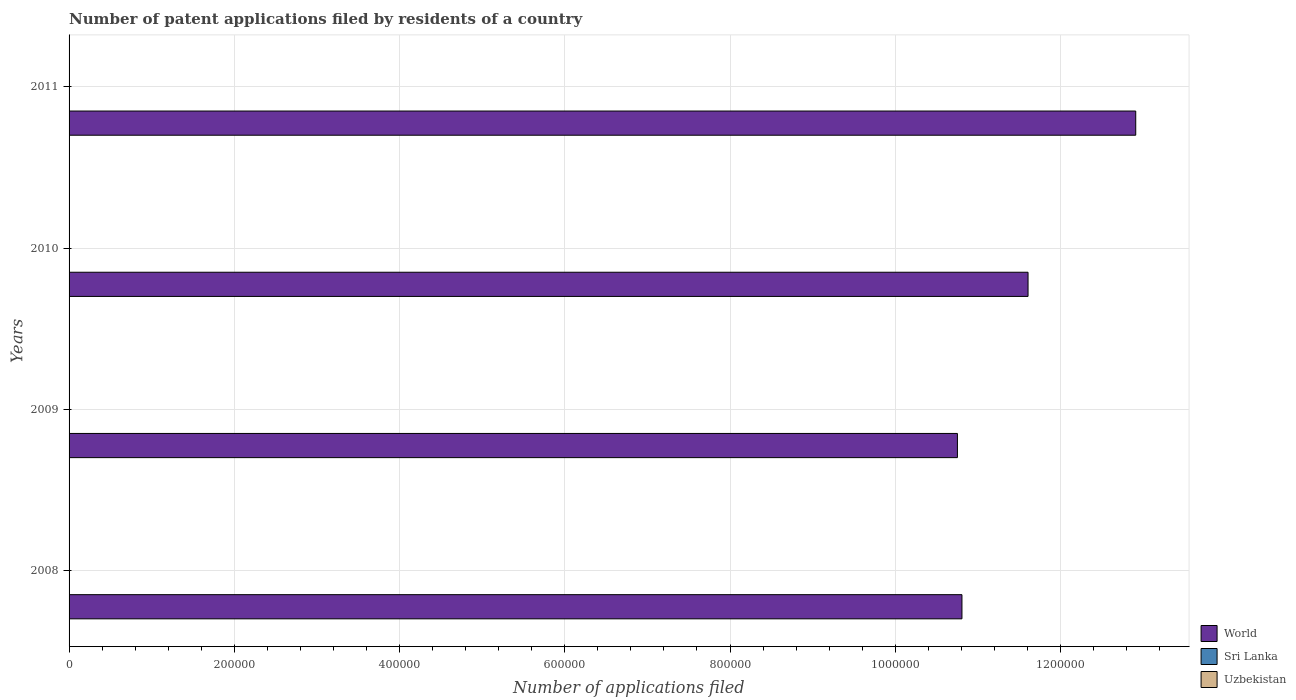How many different coloured bars are there?
Offer a terse response. 3. How many groups of bars are there?
Ensure brevity in your answer.  4. Are the number of bars per tick equal to the number of legend labels?
Make the answer very short. Yes. How many bars are there on the 2nd tick from the top?
Your response must be concise. 3. What is the number of applications filed in World in 2011?
Your response must be concise. 1.29e+06. Across all years, what is the maximum number of applications filed in Sri Lanka?
Offer a very short reply. 225. Across all years, what is the minimum number of applications filed in Uzbekistan?
Provide a short and direct response. 238. In which year was the number of applications filed in Sri Lanka maximum?
Your answer should be very brief. 2010. In which year was the number of applications filed in Sri Lanka minimum?
Keep it short and to the point. 2011. What is the total number of applications filed in Sri Lanka in the graph?
Offer a terse response. 822. What is the difference between the number of applications filed in Sri Lanka in 2010 and that in 2011?
Ensure brevity in your answer.  31. What is the difference between the number of applications filed in World in 2011 and the number of applications filed in Uzbekistan in 2008?
Provide a short and direct response. 1.29e+06. What is the average number of applications filed in Uzbekistan per year?
Make the answer very short. 288. In the year 2008, what is the difference between the number of applications filed in World and number of applications filed in Sri Lanka?
Offer a terse response. 1.08e+06. In how many years, is the number of applications filed in Sri Lanka greater than 880000 ?
Offer a very short reply. 0. What is the ratio of the number of applications filed in World in 2009 to that in 2010?
Offer a terse response. 0.93. Is the difference between the number of applications filed in World in 2010 and 2011 greater than the difference between the number of applications filed in Sri Lanka in 2010 and 2011?
Provide a short and direct response. No. What is the difference between the highest and the lowest number of applications filed in Uzbekistan?
Your answer should be compact. 132. What does the 2nd bar from the top in 2009 represents?
Provide a short and direct response. Sri Lanka. What does the 2nd bar from the bottom in 2008 represents?
Provide a short and direct response. Sri Lanka. How many bars are there?
Your response must be concise. 12. What is the difference between two consecutive major ticks on the X-axis?
Your answer should be compact. 2.00e+05. What is the title of the graph?
Ensure brevity in your answer.  Number of patent applications filed by residents of a country. What is the label or title of the X-axis?
Provide a succinct answer. Number of applications filed. What is the label or title of the Y-axis?
Give a very brief answer. Years. What is the Number of applications filed of World in 2008?
Keep it short and to the point. 1.08e+06. What is the Number of applications filed in Sri Lanka in 2008?
Your answer should be very brief. 201. What is the Number of applications filed in Uzbekistan in 2008?
Provide a succinct answer. 262. What is the Number of applications filed in World in 2009?
Make the answer very short. 1.08e+06. What is the Number of applications filed in Sri Lanka in 2009?
Your answer should be compact. 202. What is the Number of applications filed in Uzbekistan in 2009?
Your response must be concise. 238. What is the Number of applications filed of World in 2010?
Your answer should be very brief. 1.16e+06. What is the Number of applications filed of Sri Lanka in 2010?
Provide a short and direct response. 225. What is the Number of applications filed in Uzbekistan in 2010?
Ensure brevity in your answer.  370. What is the Number of applications filed of World in 2011?
Make the answer very short. 1.29e+06. What is the Number of applications filed in Sri Lanka in 2011?
Keep it short and to the point. 194. What is the Number of applications filed of Uzbekistan in 2011?
Offer a terse response. 282. Across all years, what is the maximum Number of applications filed of World?
Ensure brevity in your answer.  1.29e+06. Across all years, what is the maximum Number of applications filed of Sri Lanka?
Give a very brief answer. 225. Across all years, what is the maximum Number of applications filed in Uzbekistan?
Your answer should be very brief. 370. Across all years, what is the minimum Number of applications filed of World?
Make the answer very short. 1.08e+06. Across all years, what is the minimum Number of applications filed of Sri Lanka?
Keep it short and to the point. 194. Across all years, what is the minimum Number of applications filed of Uzbekistan?
Ensure brevity in your answer.  238. What is the total Number of applications filed in World in the graph?
Offer a very short reply. 4.61e+06. What is the total Number of applications filed in Sri Lanka in the graph?
Give a very brief answer. 822. What is the total Number of applications filed of Uzbekistan in the graph?
Keep it short and to the point. 1152. What is the difference between the Number of applications filed of World in 2008 and that in 2009?
Make the answer very short. 5490. What is the difference between the Number of applications filed of World in 2008 and that in 2010?
Your response must be concise. -8.00e+04. What is the difference between the Number of applications filed of Uzbekistan in 2008 and that in 2010?
Ensure brevity in your answer.  -108. What is the difference between the Number of applications filed of World in 2008 and that in 2011?
Provide a short and direct response. -2.10e+05. What is the difference between the Number of applications filed of Sri Lanka in 2008 and that in 2011?
Your answer should be very brief. 7. What is the difference between the Number of applications filed of Uzbekistan in 2008 and that in 2011?
Provide a short and direct response. -20. What is the difference between the Number of applications filed of World in 2009 and that in 2010?
Ensure brevity in your answer.  -8.55e+04. What is the difference between the Number of applications filed in Uzbekistan in 2009 and that in 2010?
Offer a very short reply. -132. What is the difference between the Number of applications filed of World in 2009 and that in 2011?
Give a very brief answer. -2.16e+05. What is the difference between the Number of applications filed in Sri Lanka in 2009 and that in 2011?
Offer a very short reply. 8. What is the difference between the Number of applications filed of Uzbekistan in 2009 and that in 2011?
Provide a succinct answer. -44. What is the difference between the Number of applications filed in World in 2010 and that in 2011?
Your response must be concise. -1.30e+05. What is the difference between the Number of applications filed of Uzbekistan in 2010 and that in 2011?
Give a very brief answer. 88. What is the difference between the Number of applications filed in World in 2008 and the Number of applications filed in Sri Lanka in 2009?
Offer a very short reply. 1.08e+06. What is the difference between the Number of applications filed of World in 2008 and the Number of applications filed of Uzbekistan in 2009?
Provide a succinct answer. 1.08e+06. What is the difference between the Number of applications filed of Sri Lanka in 2008 and the Number of applications filed of Uzbekistan in 2009?
Provide a succinct answer. -37. What is the difference between the Number of applications filed in World in 2008 and the Number of applications filed in Sri Lanka in 2010?
Keep it short and to the point. 1.08e+06. What is the difference between the Number of applications filed in World in 2008 and the Number of applications filed in Uzbekistan in 2010?
Keep it short and to the point. 1.08e+06. What is the difference between the Number of applications filed of Sri Lanka in 2008 and the Number of applications filed of Uzbekistan in 2010?
Make the answer very short. -169. What is the difference between the Number of applications filed of World in 2008 and the Number of applications filed of Sri Lanka in 2011?
Offer a very short reply. 1.08e+06. What is the difference between the Number of applications filed of World in 2008 and the Number of applications filed of Uzbekistan in 2011?
Provide a succinct answer. 1.08e+06. What is the difference between the Number of applications filed in Sri Lanka in 2008 and the Number of applications filed in Uzbekistan in 2011?
Offer a very short reply. -81. What is the difference between the Number of applications filed in World in 2009 and the Number of applications filed in Sri Lanka in 2010?
Provide a succinct answer. 1.08e+06. What is the difference between the Number of applications filed of World in 2009 and the Number of applications filed of Uzbekistan in 2010?
Provide a succinct answer. 1.07e+06. What is the difference between the Number of applications filed of Sri Lanka in 2009 and the Number of applications filed of Uzbekistan in 2010?
Provide a short and direct response. -168. What is the difference between the Number of applications filed of World in 2009 and the Number of applications filed of Sri Lanka in 2011?
Make the answer very short. 1.08e+06. What is the difference between the Number of applications filed of World in 2009 and the Number of applications filed of Uzbekistan in 2011?
Make the answer very short. 1.07e+06. What is the difference between the Number of applications filed of Sri Lanka in 2009 and the Number of applications filed of Uzbekistan in 2011?
Keep it short and to the point. -80. What is the difference between the Number of applications filed in World in 2010 and the Number of applications filed in Sri Lanka in 2011?
Provide a succinct answer. 1.16e+06. What is the difference between the Number of applications filed in World in 2010 and the Number of applications filed in Uzbekistan in 2011?
Offer a very short reply. 1.16e+06. What is the difference between the Number of applications filed of Sri Lanka in 2010 and the Number of applications filed of Uzbekistan in 2011?
Give a very brief answer. -57. What is the average Number of applications filed of World per year?
Provide a succinct answer. 1.15e+06. What is the average Number of applications filed of Sri Lanka per year?
Provide a short and direct response. 205.5. What is the average Number of applications filed in Uzbekistan per year?
Make the answer very short. 288. In the year 2008, what is the difference between the Number of applications filed in World and Number of applications filed in Sri Lanka?
Provide a succinct answer. 1.08e+06. In the year 2008, what is the difference between the Number of applications filed in World and Number of applications filed in Uzbekistan?
Your answer should be compact. 1.08e+06. In the year 2008, what is the difference between the Number of applications filed of Sri Lanka and Number of applications filed of Uzbekistan?
Ensure brevity in your answer.  -61. In the year 2009, what is the difference between the Number of applications filed in World and Number of applications filed in Sri Lanka?
Your answer should be very brief. 1.08e+06. In the year 2009, what is the difference between the Number of applications filed in World and Number of applications filed in Uzbekistan?
Offer a terse response. 1.08e+06. In the year 2009, what is the difference between the Number of applications filed of Sri Lanka and Number of applications filed of Uzbekistan?
Give a very brief answer. -36. In the year 2010, what is the difference between the Number of applications filed of World and Number of applications filed of Sri Lanka?
Make the answer very short. 1.16e+06. In the year 2010, what is the difference between the Number of applications filed of World and Number of applications filed of Uzbekistan?
Give a very brief answer. 1.16e+06. In the year 2010, what is the difference between the Number of applications filed in Sri Lanka and Number of applications filed in Uzbekistan?
Make the answer very short. -145. In the year 2011, what is the difference between the Number of applications filed in World and Number of applications filed in Sri Lanka?
Ensure brevity in your answer.  1.29e+06. In the year 2011, what is the difference between the Number of applications filed of World and Number of applications filed of Uzbekistan?
Ensure brevity in your answer.  1.29e+06. In the year 2011, what is the difference between the Number of applications filed in Sri Lanka and Number of applications filed in Uzbekistan?
Provide a succinct answer. -88. What is the ratio of the Number of applications filed of World in 2008 to that in 2009?
Make the answer very short. 1.01. What is the ratio of the Number of applications filed in Sri Lanka in 2008 to that in 2009?
Your answer should be very brief. 0.99. What is the ratio of the Number of applications filed of Uzbekistan in 2008 to that in 2009?
Ensure brevity in your answer.  1.1. What is the ratio of the Number of applications filed in World in 2008 to that in 2010?
Your answer should be very brief. 0.93. What is the ratio of the Number of applications filed of Sri Lanka in 2008 to that in 2010?
Your answer should be very brief. 0.89. What is the ratio of the Number of applications filed in Uzbekistan in 2008 to that in 2010?
Give a very brief answer. 0.71. What is the ratio of the Number of applications filed in World in 2008 to that in 2011?
Your answer should be very brief. 0.84. What is the ratio of the Number of applications filed of Sri Lanka in 2008 to that in 2011?
Provide a succinct answer. 1.04. What is the ratio of the Number of applications filed in Uzbekistan in 2008 to that in 2011?
Provide a succinct answer. 0.93. What is the ratio of the Number of applications filed of World in 2009 to that in 2010?
Your answer should be very brief. 0.93. What is the ratio of the Number of applications filed of Sri Lanka in 2009 to that in 2010?
Ensure brevity in your answer.  0.9. What is the ratio of the Number of applications filed of Uzbekistan in 2009 to that in 2010?
Keep it short and to the point. 0.64. What is the ratio of the Number of applications filed of World in 2009 to that in 2011?
Your response must be concise. 0.83. What is the ratio of the Number of applications filed of Sri Lanka in 2009 to that in 2011?
Make the answer very short. 1.04. What is the ratio of the Number of applications filed in Uzbekistan in 2009 to that in 2011?
Provide a short and direct response. 0.84. What is the ratio of the Number of applications filed in World in 2010 to that in 2011?
Offer a very short reply. 0.9. What is the ratio of the Number of applications filed in Sri Lanka in 2010 to that in 2011?
Ensure brevity in your answer.  1.16. What is the ratio of the Number of applications filed of Uzbekistan in 2010 to that in 2011?
Keep it short and to the point. 1.31. What is the difference between the highest and the second highest Number of applications filed in World?
Give a very brief answer. 1.30e+05. What is the difference between the highest and the second highest Number of applications filed of Sri Lanka?
Keep it short and to the point. 23. What is the difference between the highest and the second highest Number of applications filed of Uzbekistan?
Ensure brevity in your answer.  88. What is the difference between the highest and the lowest Number of applications filed of World?
Your answer should be very brief. 2.16e+05. What is the difference between the highest and the lowest Number of applications filed in Uzbekistan?
Give a very brief answer. 132. 